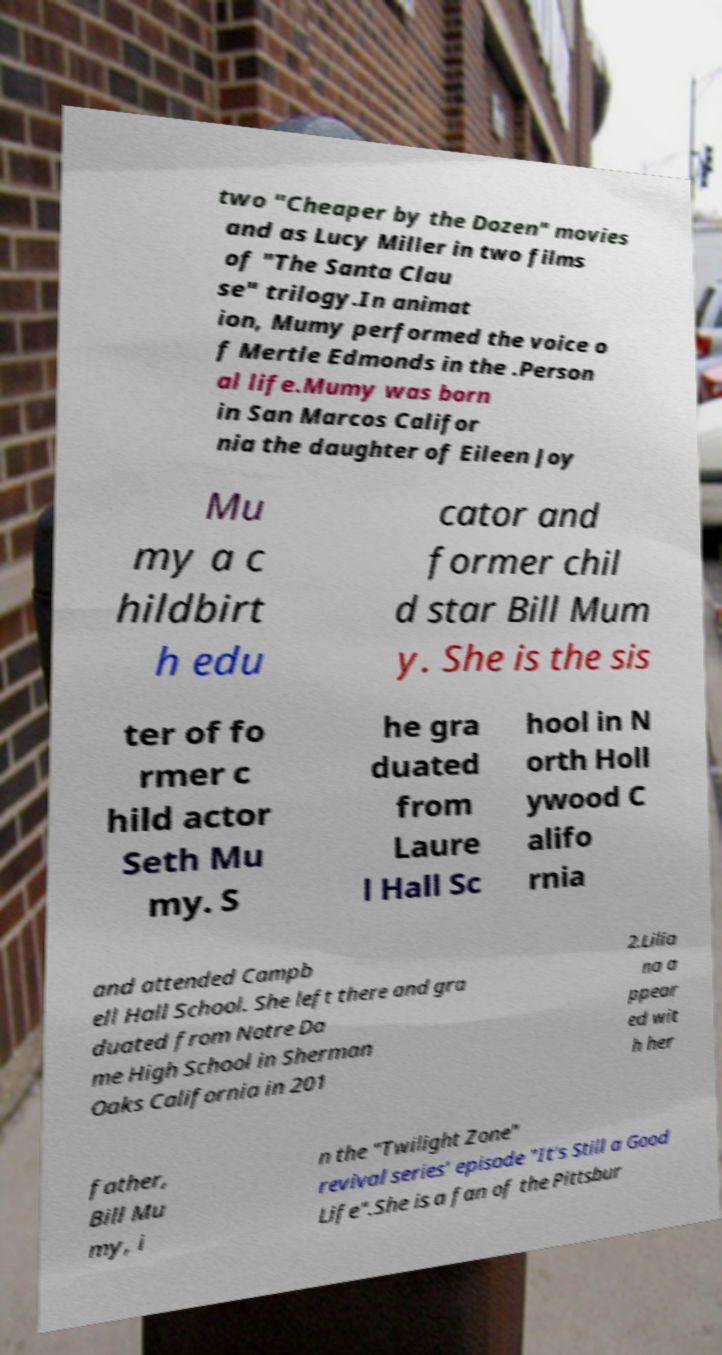Could you extract and type out the text from this image? two "Cheaper by the Dozen" movies and as Lucy Miller in two films of "The Santa Clau se" trilogy.In animat ion, Mumy performed the voice o f Mertle Edmonds in the .Person al life.Mumy was born in San Marcos Califor nia the daughter of Eileen Joy Mu my a c hildbirt h edu cator and former chil d star Bill Mum y. She is the sis ter of fo rmer c hild actor Seth Mu my. S he gra duated from Laure l Hall Sc hool in N orth Holl ywood C alifo rnia and attended Campb ell Hall School. She left there and gra duated from Notre Da me High School in Sherman Oaks California in 201 2.Lilia na a ppear ed wit h her father, Bill Mu my, i n the "Twilight Zone" revival series' episode "It's Still a Good Life".She is a fan of the Pittsbur 